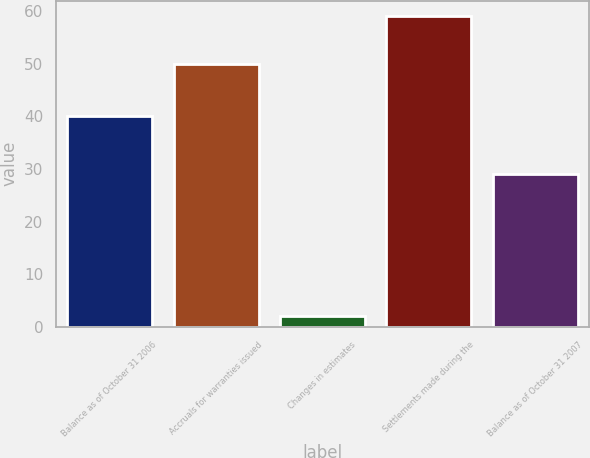<chart> <loc_0><loc_0><loc_500><loc_500><bar_chart><fcel>Balance as of October 31 2006<fcel>Accruals for warranties issued<fcel>Changes in estimates<fcel>Settlements made during the<fcel>Balance as of October 31 2007<nl><fcel>40<fcel>50<fcel>2<fcel>59<fcel>29<nl></chart> 